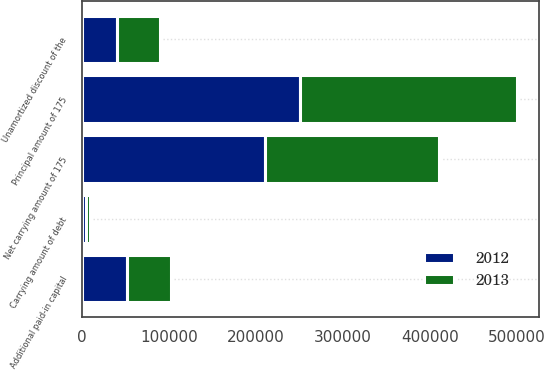Convert chart to OTSL. <chart><loc_0><loc_0><loc_500><loc_500><stacked_bar_chart><ecel><fcel>Additional paid-in capital<fcel>Principal amount of 175<fcel>Unamortized discount of the<fcel>Net carrying amount of 175<fcel>Carrying amount of debt<nl><fcel>2012<fcel>51180<fcel>250000<fcel>39979<fcel>210021<fcel>3821<nl><fcel>2013<fcel>51180<fcel>250000<fcel>49291<fcel>200709<fcel>4979<nl></chart> 